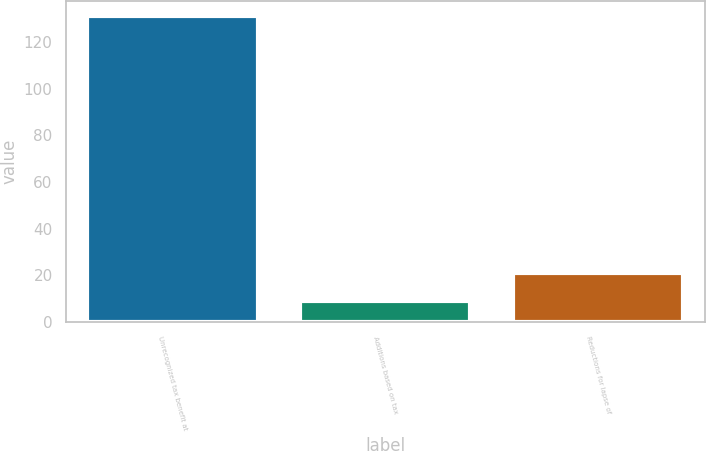Convert chart to OTSL. <chart><loc_0><loc_0><loc_500><loc_500><bar_chart><fcel>Unrecognized tax benefit at<fcel>Additions based on tax<fcel>Reductions for lapse of<nl><fcel>131<fcel>9<fcel>21.2<nl></chart> 